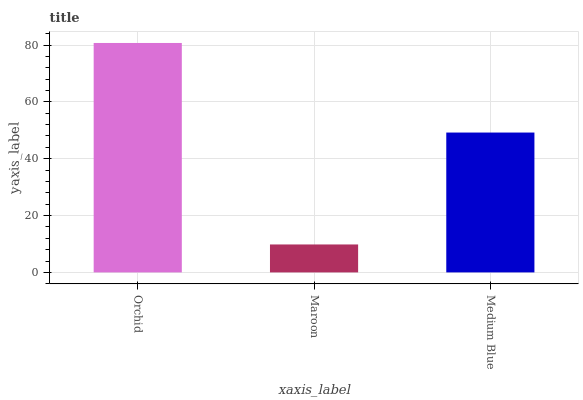Is Maroon the minimum?
Answer yes or no. Yes. Is Orchid the maximum?
Answer yes or no. Yes. Is Medium Blue the minimum?
Answer yes or no. No. Is Medium Blue the maximum?
Answer yes or no. No. Is Medium Blue greater than Maroon?
Answer yes or no. Yes. Is Maroon less than Medium Blue?
Answer yes or no. Yes. Is Maroon greater than Medium Blue?
Answer yes or no. No. Is Medium Blue less than Maroon?
Answer yes or no. No. Is Medium Blue the high median?
Answer yes or no. Yes. Is Medium Blue the low median?
Answer yes or no. Yes. Is Orchid the high median?
Answer yes or no. No. Is Orchid the low median?
Answer yes or no. No. 